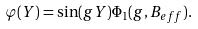Convert formula to latex. <formula><loc_0><loc_0><loc_500><loc_500>\varphi ( Y ) = \sin ( g Y ) \Phi _ { 1 } ( g , B _ { e f f } ) .</formula> 